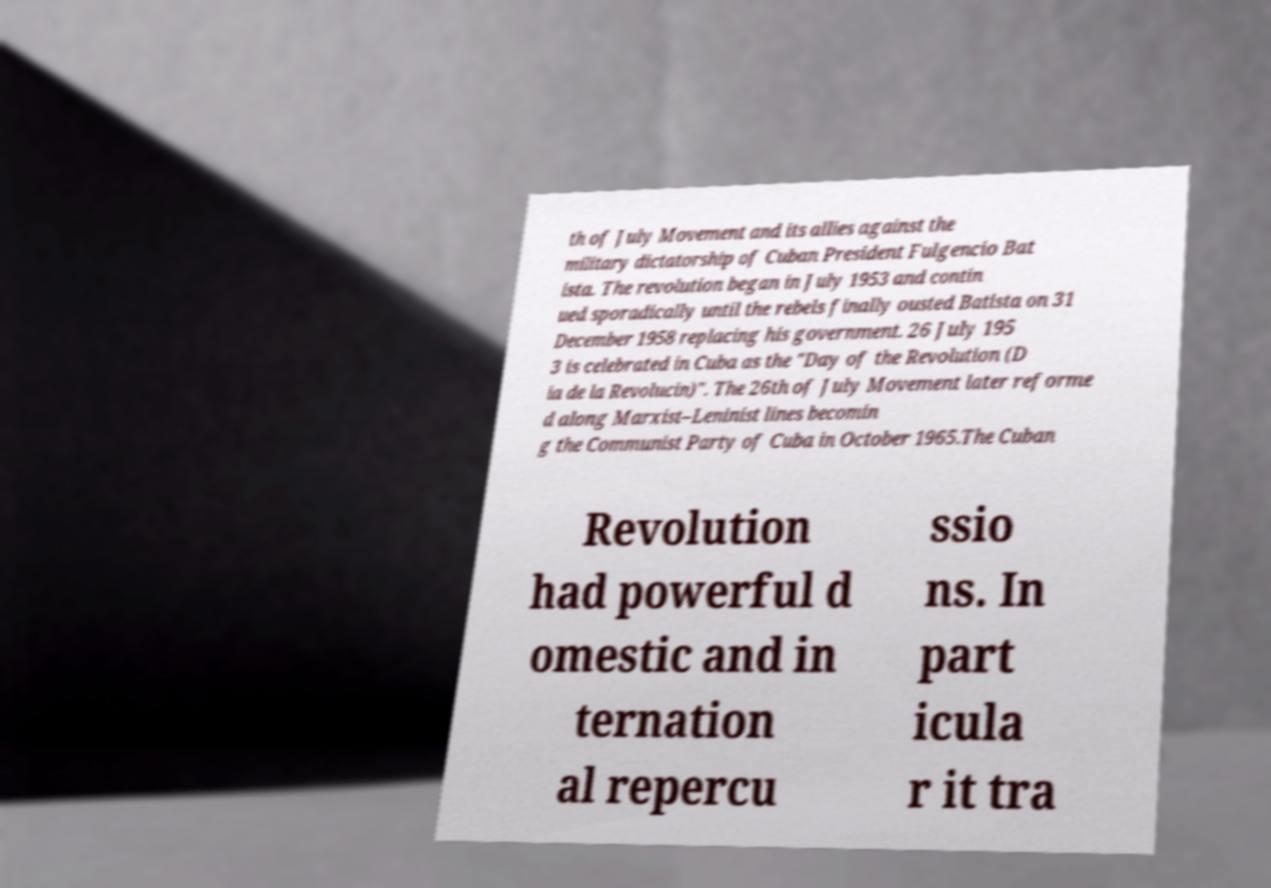Can you accurately transcribe the text from the provided image for me? th of July Movement and its allies against the military dictatorship of Cuban President Fulgencio Bat ista. The revolution began in July 1953 and contin ued sporadically until the rebels finally ousted Batista on 31 December 1958 replacing his government. 26 July 195 3 is celebrated in Cuba as the "Day of the Revolution (D ia de la Revolucin)". The 26th of July Movement later reforme d along Marxist–Leninist lines becomin g the Communist Party of Cuba in October 1965.The Cuban Revolution had powerful d omestic and in ternation al repercu ssio ns. In part icula r it tra 